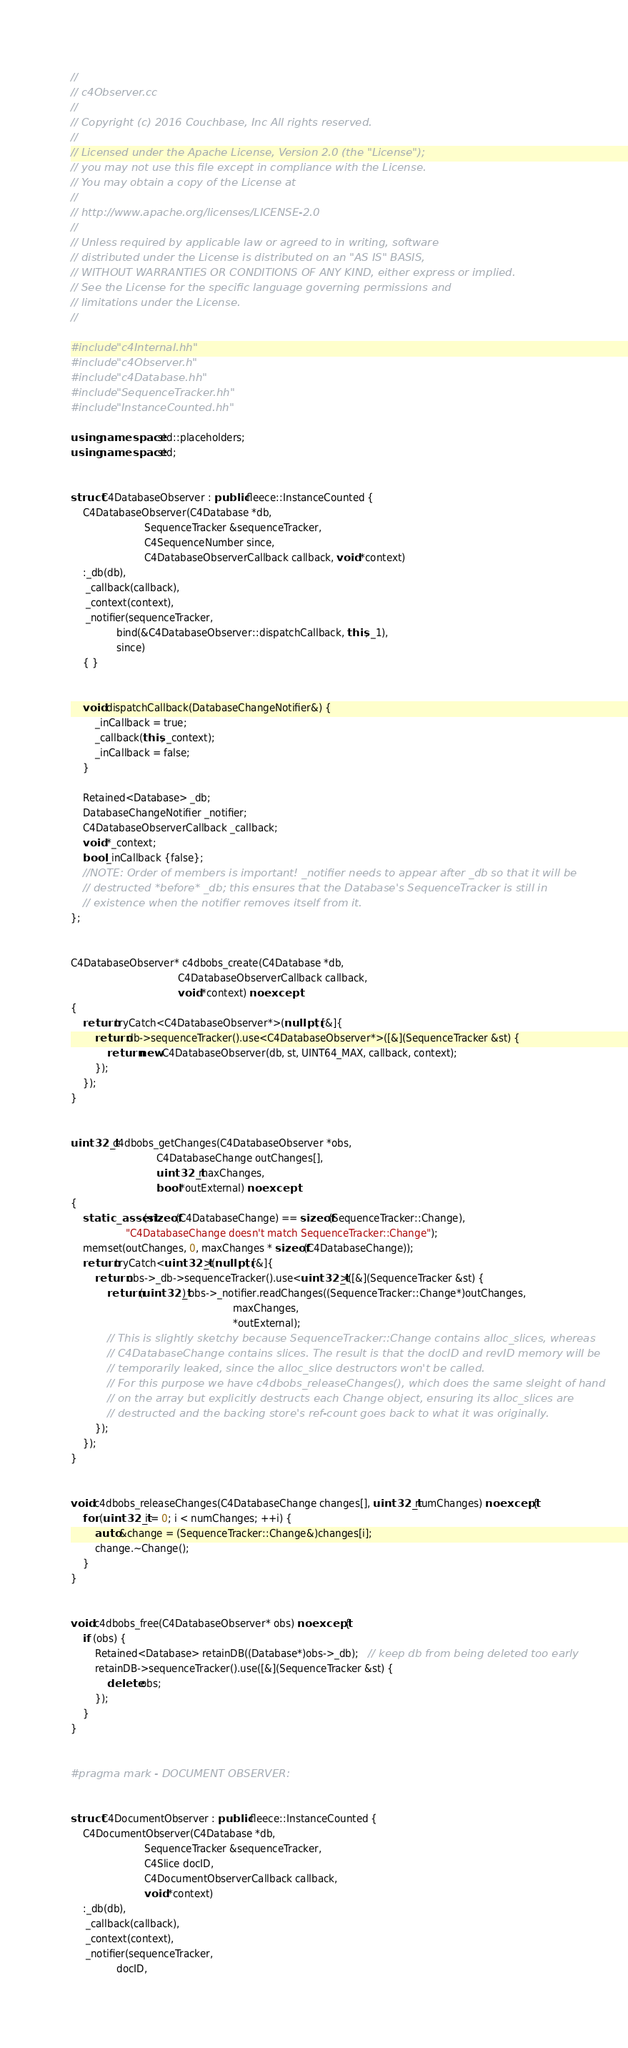<code> <loc_0><loc_0><loc_500><loc_500><_C++_>//
// c4Observer.cc
//
// Copyright (c) 2016 Couchbase, Inc All rights reserved.
//
// Licensed under the Apache License, Version 2.0 (the "License");
// you may not use this file except in compliance with the License.
// You may obtain a copy of the License at
//
// http://www.apache.org/licenses/LICENSE-2.0
//
// Unless required by applicable law or agreed to in writing, software
// distributed under the License is distributed on an "AS IS" BASIS,
// WITHOUT WARRANTIES OR CONDITIONS OF ANY KIND, either express or implied.
// See the License for the specific language governing permissions and
// limitations under the License.
//

#include "c4Internal.hh"
#include "c4Observer.h"
#include "c4Database.hh"
#include "SequenceTracker.hh"
#include "InstanceCounted.hh"

using namespace std::placeholders;
using namespace std;


struct C4DatabaseObserver : public fleece::InstanceCounted {
    C4DatabaseObserver(C4Database *db,
                        SequenceTracker &sequenceTracker,
                        C4SequenceNumber since,
                        C4DatabaseObserverCallback callback, void *context)
    :_db(db),
     _callback(callback),
     _context(context),
     _notifier(sequenceTracker,
               bind(&C4DatabaseObserver::dispatchCallback, this, _1),
               since)
    { }


    void dispatchCallback(DatabaseChangeNotifier&) {
        _inCallback = true;
        _callback(this, _context);
        _inCallback = false;
    }

    Retained<Database> _db;
    DatabaseChangeNotifier _notifier;
    C4DatabaseObserverCallback _callback;
    void *_context;
    bool _inCallback {false};
    //NOTE: Order of members is important! _notifier needs to appear after _db so that it will be
    // destructed *before* _db; this ensures that the Database's SequenceTracker is still in
    // existence when the notifier removes itself from it.
};


C4DatabaseObserver* c4dbobs_create(C4Database *db,
                                   C4DatabaseObserverCallback callback,
                                   void *context) noexcept
{
    return tryCatch<C4DatabaseObserver*>(nullptr, [&]{
        return db->sequenceTracker().use<C4DatabaseObserver*>([&](SequenceTracker &st) {
            return new C4DatabaseObserver(db, st, UINT64_MAX, callback, context);
        });
    });
}


uint32_t c4dbobs_getChanges(C4DatabaseObserver *obs,
                            C4DatabaseChange outChanges[],
                            uint32_t maxChanges,
                            bool *outExternal) noexcept
{
    static_assert(sizeof(C4DatabaseChange) == sizeof(SequenceTracker::Change),
                  "C4DatabaseChange doesn't match SequenceTracker::Change");
    memset(outChanges, 0, maxChanges * sizeof(C4DatabaseChange));
    return tryCatch<uint32_t>(nullptr, [&]{
        return obs->_db->sequenceTracker().use<uint32_t>([&](SequenceTracker &st) {
            return (uint32_t) obs->_notifier.readChanges((SequenceTracker::Change*)outChanges,
                                                     maxChanges,
                                                     *outExternal);
            // This is slightly sketchy because SequenceTracker::Change contains alloc_slices, whereas
            // C4DatabaseChange contains slices. The result is that the docID and revID memory will be
            // temporarily leaked, since the alloc_slice destructors won't be called.
            // For this purpose we have c4dbobs_releaseChanges(), which does the same sleight of hand
            // on the array but explicitly destructs each Change object, ensuring its alloc_slices are
            // destructed and the backing store's ref-count goes back to what it was originally.
        });
    });
}


void c4dbobs_releaseChanges(C4DatabaseChange changes[], uint32_t numChanges) noexcept {
    for (uint32_t i = 0; i < numChanges; ++i) {
        auto &change = (SequenceTracker::Change&)changes[i];
        change.~Change();
    }
}


void c4dbobs_free(C4DatabaseObserver* obs) noexcept {
    if (obs) {
        Retained<Database> retainDB((Database*)obs->_db);   // keep db from being deleted too early
        retainDB->sequenceTracker().use([&](SequenceTracker &st) {
            delete obs;
        });
    }
}


#pragma mark - DOCUMENT OBSERVER:


struct C4DocumentObserver : public fleece::InstanceCounted {
    C4DocumentObserver(C4Database *db,
                        SequenceTracker &sequenceTracker,
                        C4Slice docID,
                        C4DocumentObserverCallback callback,
                        void *context)
    :_db(db),
     _callback(callback),
     _context(context),
     _notifier(sequenceTracker,
               docID,</code> 